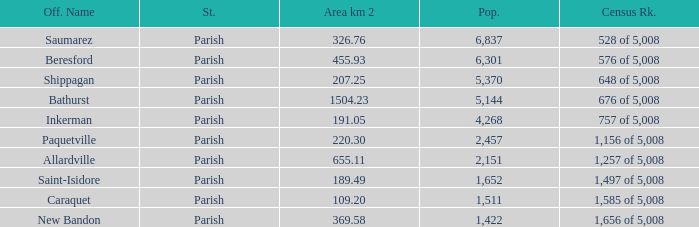What is the Population of the New Bandon Parish with an Area km 2 larger than 326.76? 1422.0. 